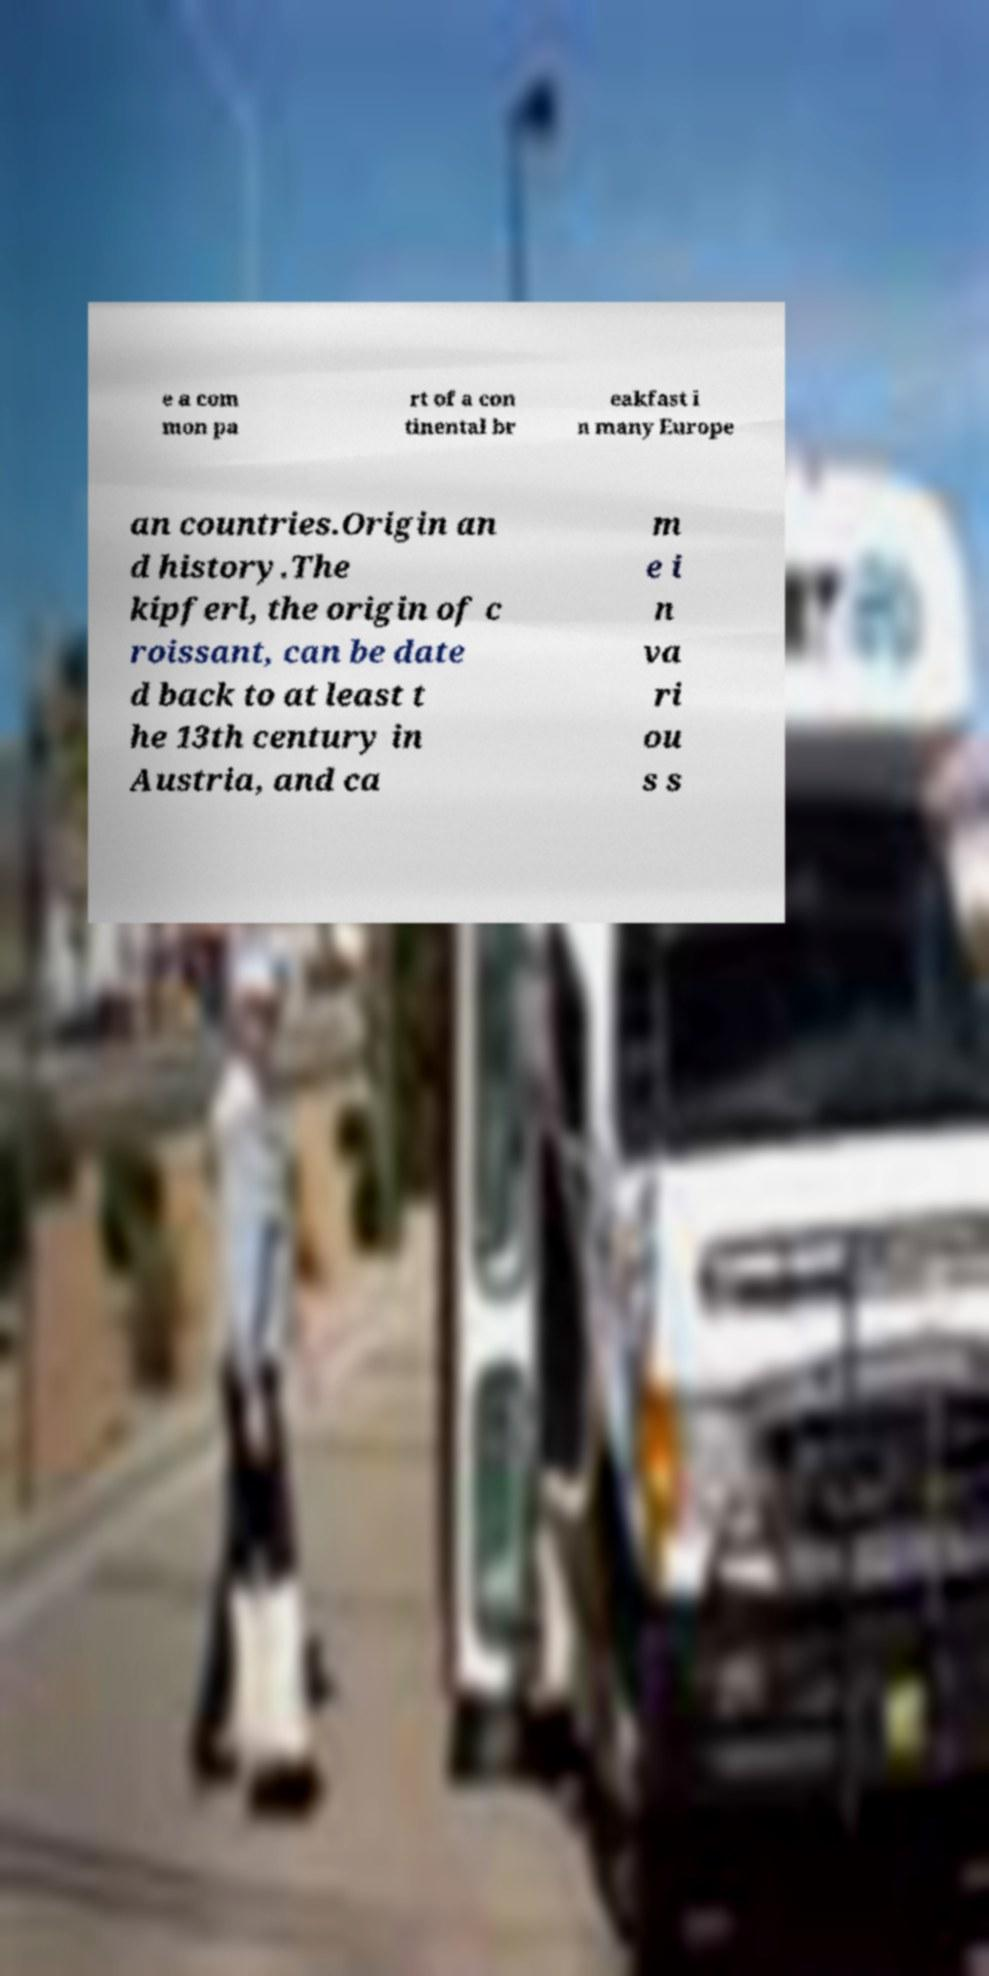Can you read and provide the text displayed in the image?This photo seems to have some interesting text. Can you extract and type it out for me? e a com mon pa rt of a con tinental br eakfast i n many Europe an countries.Origin an d history.The kipferl, the origin of c roissant, can be date d back to at least t he 13th century in Austria, and ca m e i n va ri ou s s 